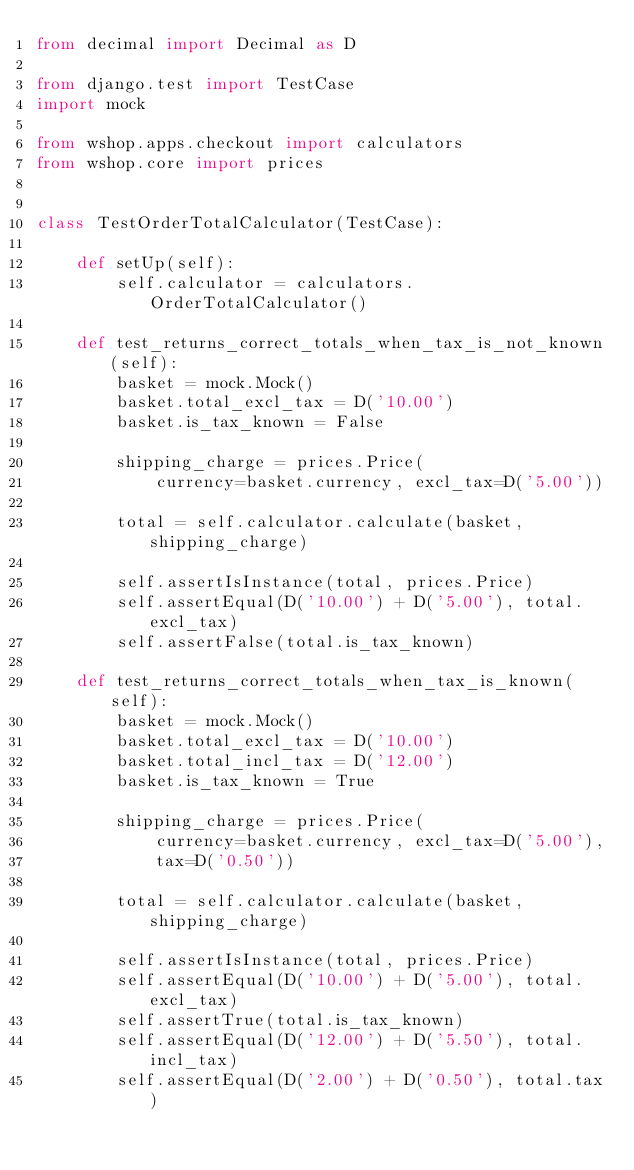Convert code to text. <code><loc_0><loc_0><loc_500><loc_500><_Python_>from decimal import Decimal as D

from django.test import TestCase
import mock

from wshop.apps.checkout import calculators
from wshop.core import prices


class TestOrderTotalCalculator(TestCase):

    def setUp(self):
        self.calculator = calculators.OrderTotalCalculator()

    def test_returns_correct_totals_when_tax_is_not_known(self):
        basket = mock.Mock()
        basket.total_excl_tax = D('10.00')
        basket.is_tax_known = False

        shipping_charge = prices.Price(
            currency=basket.currency, excl_tax=D('5.00'))

        total = self.calculator.calculate(basket, shipping_charge)

        self.assertIsInstance(total, prices.Price)
        self.assertEqual(D('10.00') + D('5.00'), total.excl_tax)
        self.assertFalse(total.is_tax_known)

    def test_returns_correct_totals_when_tax_is_known(self):
        basket = mock.Mock()
        basket.total_excl_tax = D('10.00')
        basket.total_incl_tax = D('12.00')
        basket.is_tax_known = True

        shipping_charge = prices.Price(
            currency=basket.currency, excl_tax=D('5.00'),
            tax=D('0.50'))

        total = self.calculator.calculate(basket, shipping_charge)

        self.assertIsInstance(total, prices.Price)
        self.assertEqual(D('10.00') + D('5.00'), total.excl_tax)
        self.assertTrue(total.is_tax_known)
        self.assertEqual(D('12.00') + D('5.50'), total.incl_tax)
        self.assertEqual(D('2.00') + D('0.50'), total.tax)
</code> 